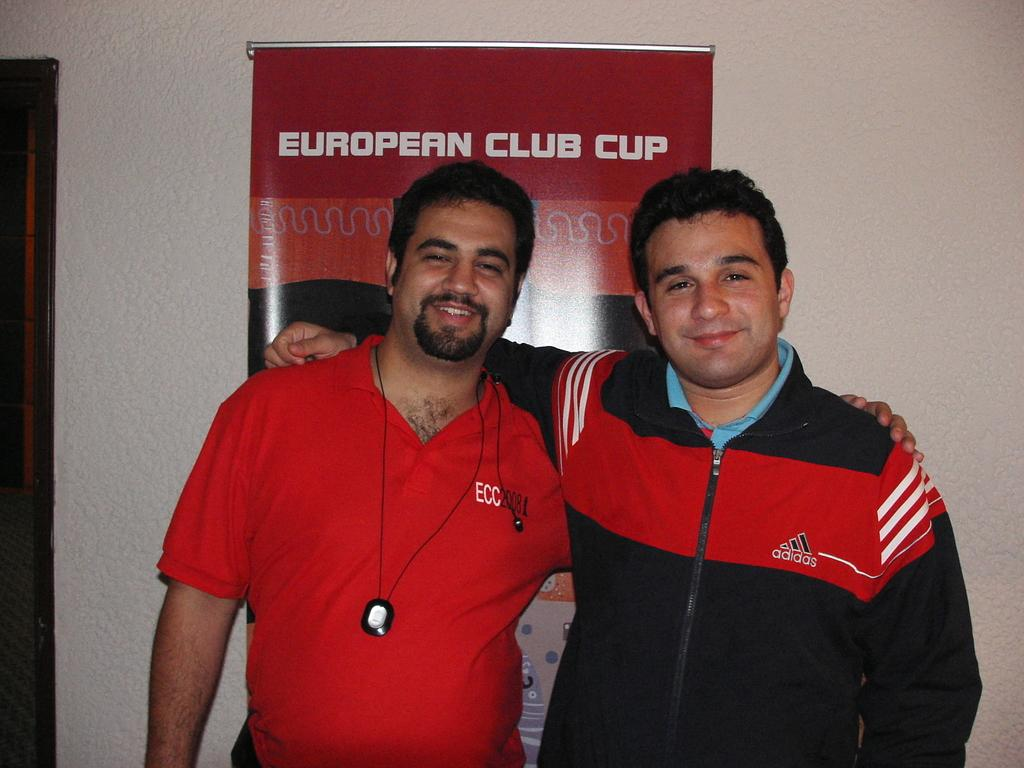<image>
Render a clear and concise summary of the photo. Two men have their arms around each other in front of a European Club Cup poster. 